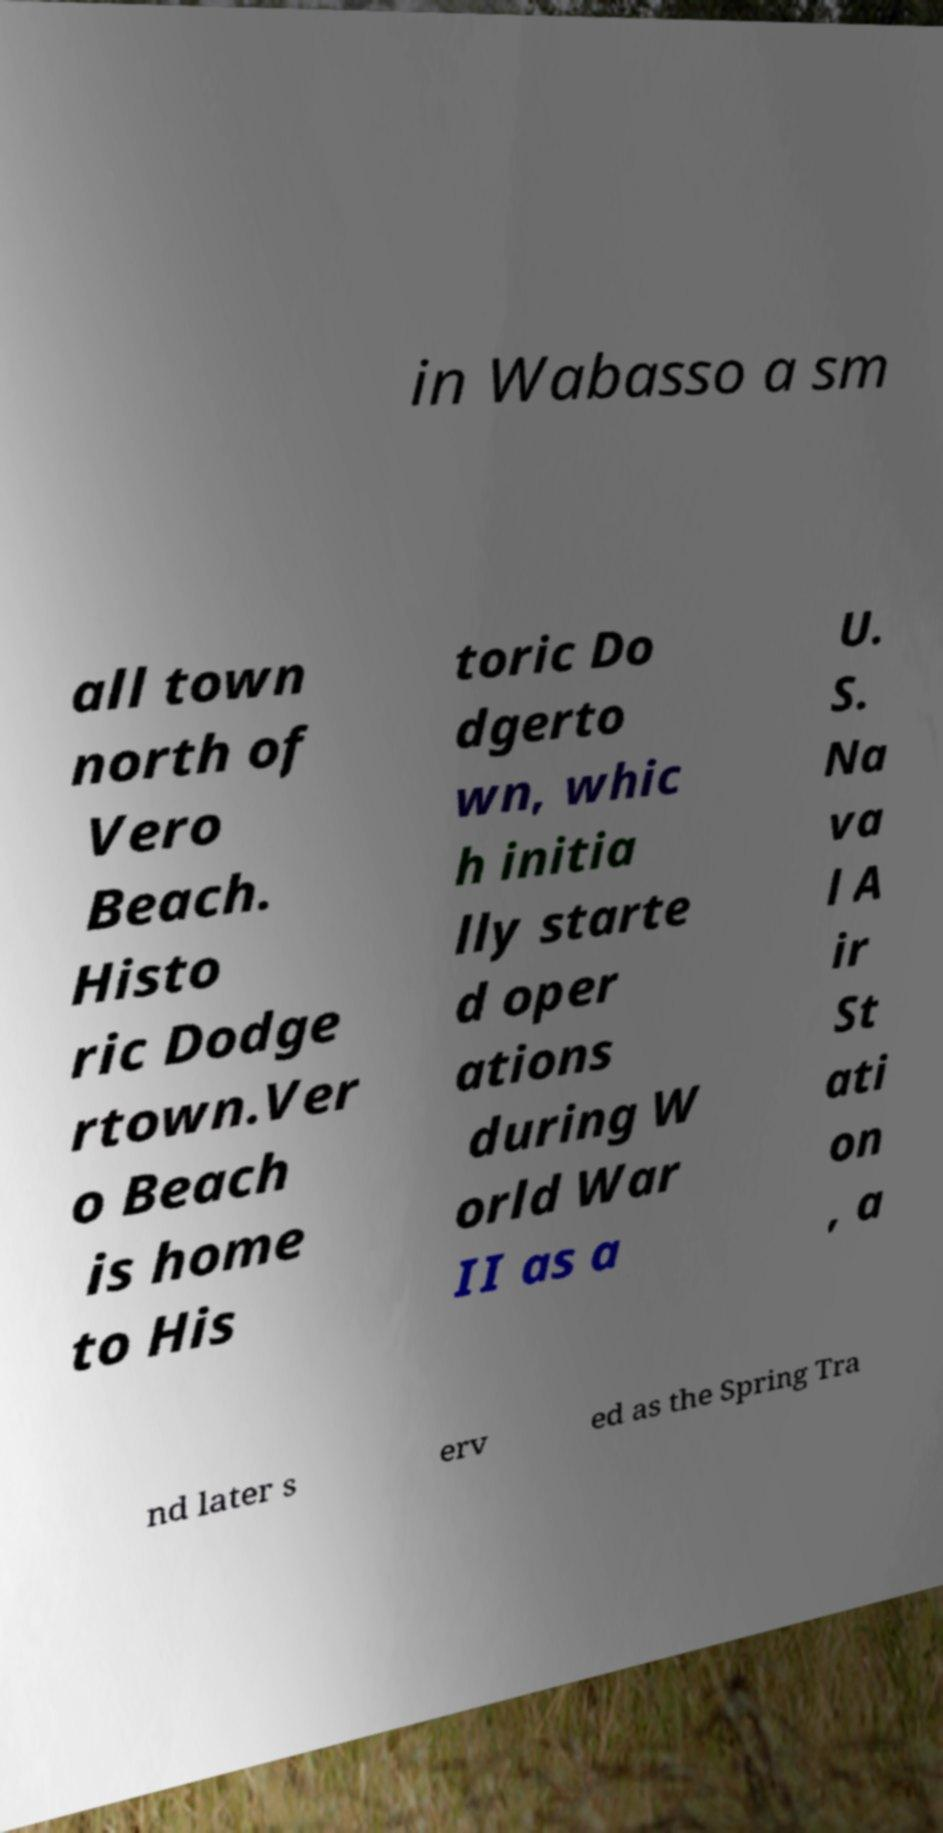What messages or text are displayed in this image? I need them in a readable, typed format. in Wabasso a sm all town north of Vero Beach. Histo ric Dodge rtown.Ver o Beach is home to His toric Do dgerto wn, whic h initia lly starte d oper ations during W orld War II as a U. S. Na va l A ir St ati on , a nd later s erv ed as the Spring Tra 